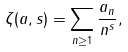<formula> <loc_0><loc_0><loc_500><loc_500>\zeta ( a , s ) = \sum _ { n \geq 1 } \frac { a _ { n } } { n ^ { s } } ,</formula> 